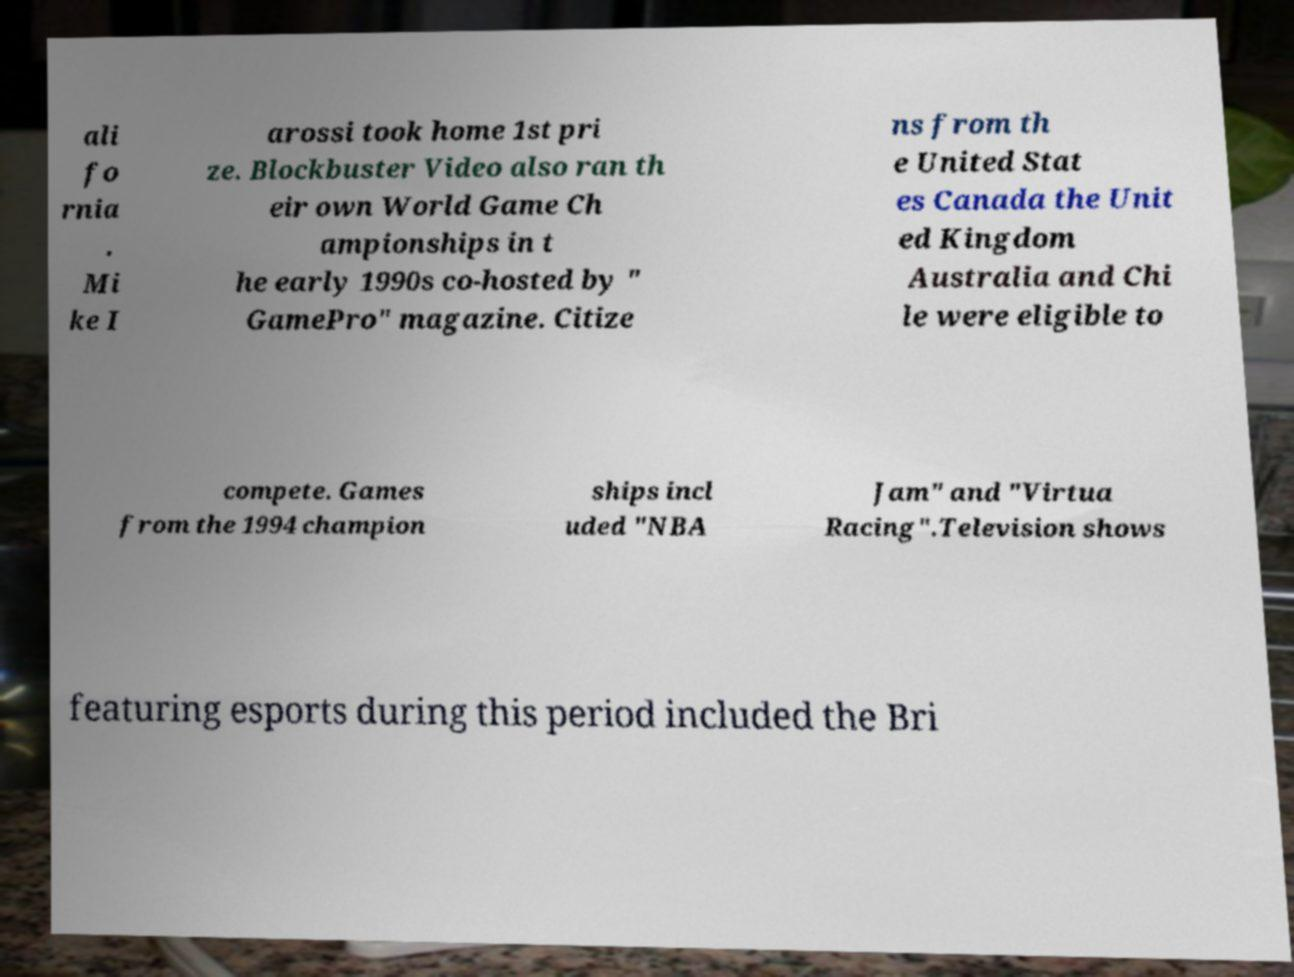Please read and relay the text visible in this image. What does it say? ali fo rnia . Mi ke I arossi took home 1st pri ze. Blockbuster Video also ran th eir own World Game Ch ampionships in t he early 1990s co-hosted by " GamePro" magazine. Citize ns from th e United Stat es Canada the Unit ed Kingdom Australia and Chi le were eligible to compete. Games from the 1994 champion ships incl uded "NBA Jam" and "Virtua Racing".Television shows featuring esports during this period included the Bri 